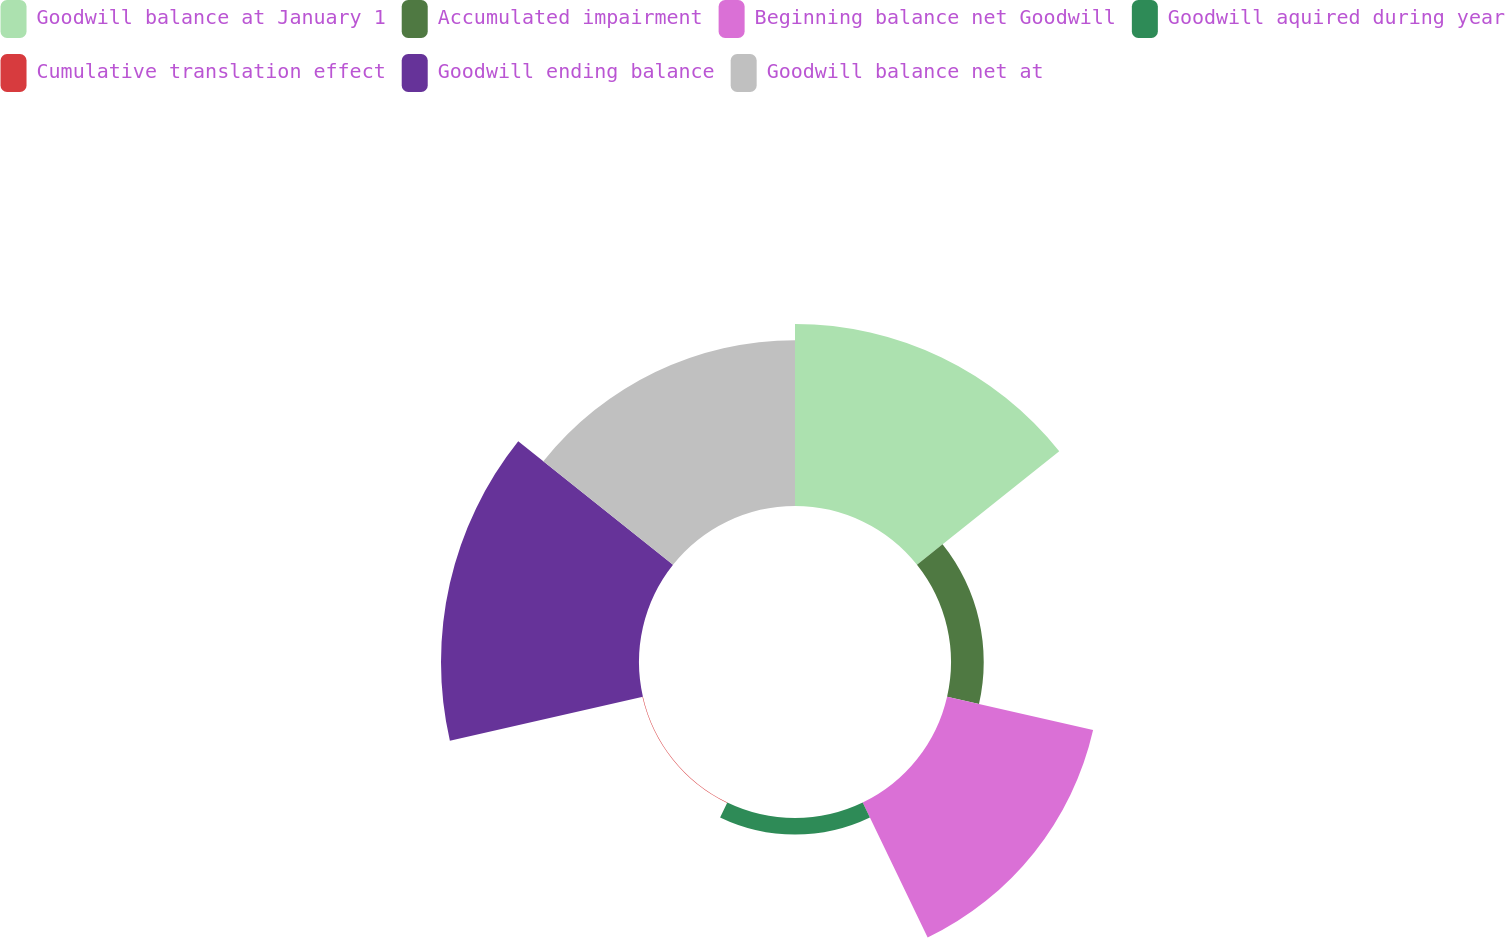Convert chart. <chart><loc_0><loc_0><loc_500><loc_500><pie_chart><fcel>Goodwill balance at January 1<fcel>Accumulated impairment<fcel>Beginning balance net Goodwill<fcel>Goodwill aquired during year<fcel>Cumulative translation effect<fcel>Goodwill ending balance<fcel>Goodwill balance net at<nl><fcel>24.41%<fcel>4.39%<fcel>20.09%<fcel>2.23%<fcel>0.07%<fcel>26.56%<fcel>22.25%<nl></chart> 